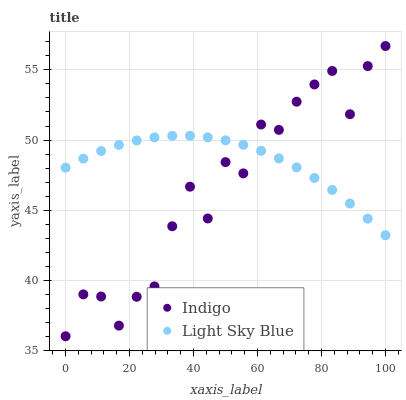Does Indigo have the minimum area under the curve?
Answer yes or no. Yes. Does Light Sky Blue have the maximum area under the curve?
Answer yes or no. Yes. Does Indigo have the maximum area under the curve?
Answer yes or no. No. Is Light Sky Blue the smoothest?
Answer yes or no. Yes. Is Indigo the roughest?
Answer yes or no. Yes. Is Indigo the smoothest?
Answer yes or no. No. Does Indigo have the lowest value?
Answer yes or no. Yes. Does Indigo have the highest value?
Answer yes or no. Yes. Does Light Sky Blue intersect Indigo?
Answer yes or no. Yes. Is Light Sky Blue less than Indigo?
Answer yes or no. No. Is Light Sky Blue greater than Indigo?
Answer yes or no. No. 